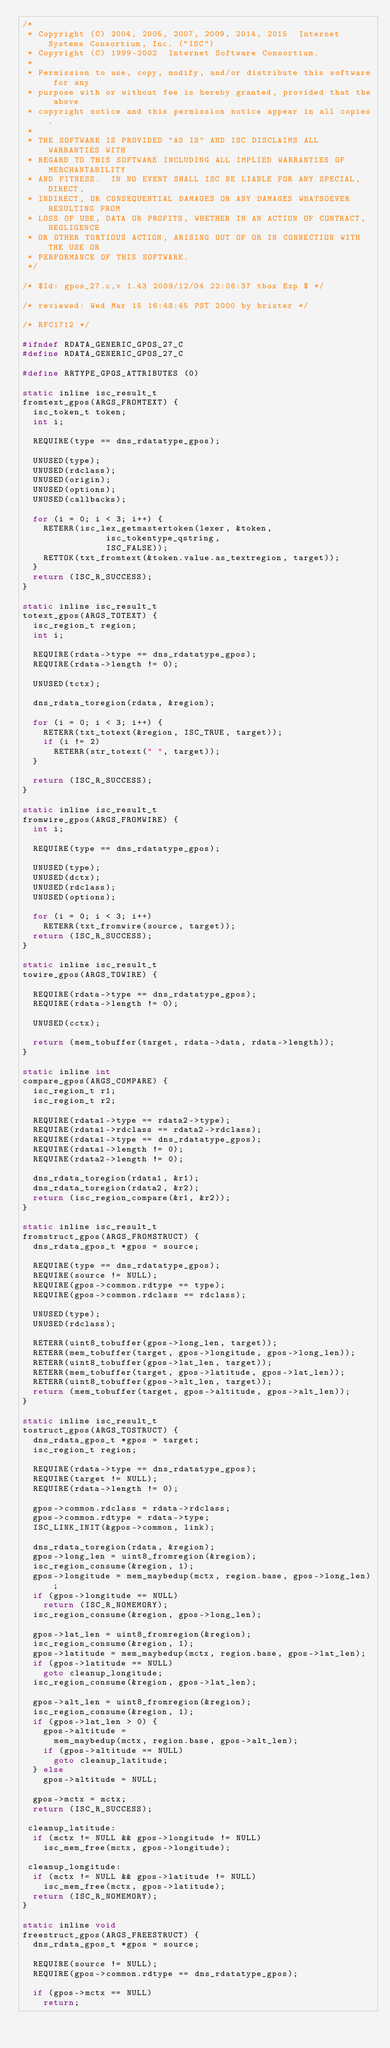Convert code to text. <code><loc_0><loc_0><loc_500><loc_500><_C_>/*
 * Copyright (C) 2004, 2005, 2007, 2009, 2014, 2015  Internet Systems Consortium, Inc. ("ISC")
 * Copyright (C) 1999-2002  Internet Software Consortium.
 *
 * Permission to use, copy, modify, and/or distribute this software for any
 * purpose with or without fee is hereby granted, provided that the above
 * copyright notice and this permission notice appear in all copies.
 *
 * THE SOFTWARE IS PROVIDED "AS IS" AND ISC DISCLAIMS ALL WARRANTIES WITH
 * REGARD TO THIS SOFTWARE INCLUDING ALL IMPLIED WARRANTIES OF MERCHANTABILITY
 * AND FITNESS.  IN NO EVENT SHALL ISC BE LIABLE FOR ANY SPECIAL, DIRECT,
 * INDIRECT, OR CONSEQUENTIAL DAMAGES OR ANY DAMAGES WHATSOEVER RESULTING FROM
 * LOSS OF USE, DATA OR PROFITS, WHETHER IN AN ACTION OF CONTRACT, NEGLIGENCE
 * OR OTHER TORTIOUS ACTION, ARISING OUT OF OR IN CONNECTION WITH THE USE OR
 * PERFORMANCE OF THIS SOFTWARE.
 */

/* $Id: gpos_27.c,v 1.43 2009/12/04 22:06:37 tbox Exp $ */

/* reviewed: Wed Mar 15 16:48:45 PST 2000 by brister */

/* RFC1712 */

#ifndef RDATA_GENERIC_GPOS_27_C
#define RDATA_GENERIC_GPOS_27_C

#define RRTYPE_GPOS_ATTRIBUTES (0)

static inline isc_result_t
fromtext_gpos(ARGS_FROMTEXT) {
	isc_token_t token;
	int i;

	REQUIRE(type == dns_rdatatype_gpos);

	UNUSED(type);
	UNUSED(rdclass);
	UNUSED(origin);
	UNUSED(options);
	UNUSED(callbacks);

	for (i = 0; i < 3; i++) {
		RETERR(isc_lex_getmastertoken(lexer, &token,
					      isc_tokentype_qstring,
					      ISC_FALSE));
		RETTOK(txt_fromtext(&token.value.as_textregion, target));
	}
	return (ISC_R_SUCCESS);
}

static inline isc_result_t
totext_gpos(ARGS_TOTEXT) {
	isc_region_t region;
	int i;

	REQUIRE(rdata->type == dns_rdatatype_gpos);
	REQUIRE(rdata->length != 0);

	UNUSED(tctx);

	dns_rdata_toregion(rdata, &region);

	for (i = 0; i < 3; i++) {
		RETERR(txt_totext(&region, ISC_TRUE, target));
		if (i != 2)
			RETERR(str_totext(" ", target));
	}

	return (ISC_R_SUCCESS);
}

static inline isc_result_t
fromwire_gpos(ARGS_FROMWIRE) {
	int i;

	REQUIRE(type == dns_rdatatype_gpos);

	UNUSED(type);
	UNUSED(dctx);
	UNUSED(rdclass);
	UNUSED(options);

	for (i = 0; i < 3; i++)
		RETERR(txt_fromwire(source, target));
	return (ISC_R_SUCCESS);
}

static inline isc_result_t
towire_gpos(ARGS_TOWIRE) {

	REQUIRE(rdata->type == dns_rdatatype_gpos);
	REQUIRE(rdata->length != 0);

	UNUSED(cctx);

	return (mem_tobuffer(target, rdata->data, rdata->length));
}

static inline int
compare_gpos(ARGS_COMPARE) {
	isc_region_t r1;
	isc_region_t r2;

	REQUIRE(rdata1->type == rdata2->type);
	REQUIRE(rdata1->rdclass == rdata2->rdclass);
	REQUIRE(rdata1->type == dns_rdatatype_gpos);
	REQUIRE(rdata1->length != 0);
	REQUIRE(rdata2->length != 0);

	dns_rdata_toregion(rdata1, &r1);
	dns_rdata_toregion(rdata2, &r2);
	return (isc_region_compare(&r1, &r2));
}

static inline isc_result_t
fromstruct_gpos(ARGS_FROMSTRUCT) {
	dns_rdata_gpos_t *gpos = source;

	REQUIRE(type == dns_rdatatype_gpos);
	REQUIRE(source != NULL);
	REQUIRE(gpos->common.rdtype == type);
	REQUIRE(gpos->common.rdclass == rdclass);

	UNUSED(type);
	UNUSED(rdclass);

	RETERR(uint8_tobuffer(gpos->long_len, target));
	RETERR(mem_tobuffer(target, gpos->longitude, gpos->long_len));
	RETERR(uint8_tobuffer(gpos->lat_len, target));
	RETERR(mem_tobuffer(target, gpos->latitude, gpos->lat_len));
	RETERR(uint8_tobuffer(gpos->alt_len, target));
	return (mem_tobuffer(target, gpos->altitude, gpos->alt_len));
}

static inline isc_result_t
tostruct_gpos(ARGS_TOSTRUCT) {
	dns_rdata_gpos_t *gpos = target;
	isc_region_t region;

	REQUIRE(rdata->type == dns_rdatatype_gpos);
	REQUIRE(target != NULL);
	REQUIRE(rdata->length != 0);

	gpos->common.rdclass = rdata->rdclass;
	gpos->common.rdtype = rdata->type;
	ISC_LINK_INIT(&gpos->common, link);

	dns_rdata_toregion(rdata, &region);
	gpos->long_len = uint8_fromregion(&region);
	isc_region_consume(&region, 1);
	gpos->longitude = mem_maybedup(mctx, region.base, gpos->long_len);
	if (gpos->longitude == NULL)
		return (ISC_R_NOMEMORY);
	isc_region_consume(&region, gpos->long_len);

	gpos->lat_len = uint8_fromregion(&region);
	isc_region_consume(&region, 1);
	gpos->latitude = mem_maybedup(mctx, region.base, gpos->lat_len);
	if (gpos->latitude == NULL)
		goto cleanup_longitude;
	isc_region_consume(&region, gpos->lat_len);

	gpos->alt_len = uint8_fromregion(&region);
	isc_region_consume(&region, 1);
	if (gpos->lat_len > 0) {
		gpos->altitude =
			mem_maybedup(mctx, region.base, gpos->alt_len);
		if (gpos->altitude == NULL)
			goto cleanup_latitude;
	} else
		gpos->altitude = NULL;

	gpos->mctx = mctx;
	return (ISC_R_SUCCESS);

 cleanup_latitude:
	if (mctx != NULL && gpos->longitude != NULL)
		isc_mem_free(mctx, gpos->longitude);

 cleanup_longitude:
	if (mctx != NULL && gpos->latitude != NULL)
		isc_mem_free(mctx, gpos->latitude);
	return (ISC_R_NOMEMORY);
}

static inline void
freestruct_gpos(ARGS_FREESTRUCT) {
	dns_rdata_gpos_t *gpos = source;

	REQUIRE(source != NULL);
	REQUIRE(gpos->common.rdtype == dns_rdatatype_gpos);

	if (gpos->mctx == NULL)
		return;
</code> 